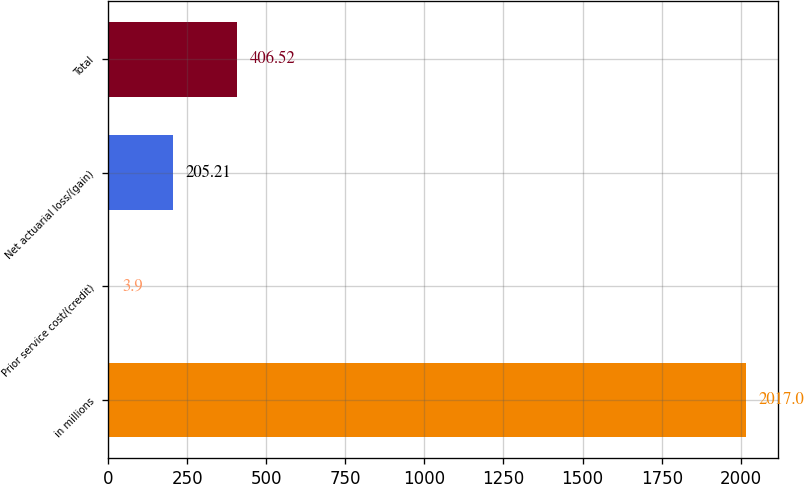<chart> <loc_0><loc_0><loc_500><loc_500><bar_chart><fcel>in millions<fcel>Prior service cost/(credit)<fcel>Net actuarial loss/(gain)<fcel>Total<nl><fcel>2017<fcel>3.9<fcel>205.21<fcel>406.52<nl></chart> 